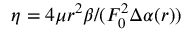<formula> <loc_0><loc_0><loc_500><loc_500>\eta = 4 \mu r ^ { 2 } \beta / ( F _ { 0 } ^ { 2 } \Delta \alpha ( r ) )</formula> 